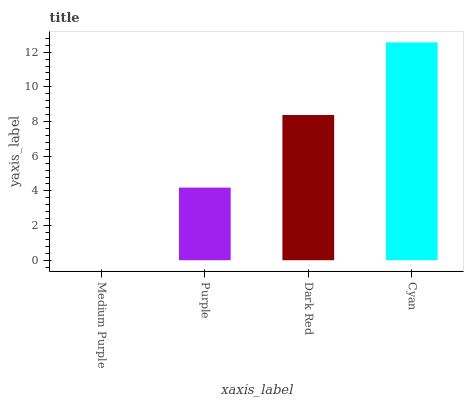Is Medium Purple the minimum?
Answer yes or no. Yes. Is Cyan the maximum?
Answer yes or no. Yes. Is Purple the minimum?
Answer yes or no. No. Is Purple the maximum?
Answer yes or no. No. Is Purple greater than Medium Purple?
Answer yes or no. Yes. Is Medium Purple less than Purple?
Answer yes or no. Yes. Is Medium Purple greater than Purple?
Answer yes or no. No. Is Purple less than Medium Purple?
Answer yes or no. No. Is Dark Red the high median?
Answer yes or no. Yes. Is Purple the low median?
Answer yes or no. Yes. Is Purple the high median?
Answer yes or no. No. Is Cyan the low median?
Answer yes or no. No. 